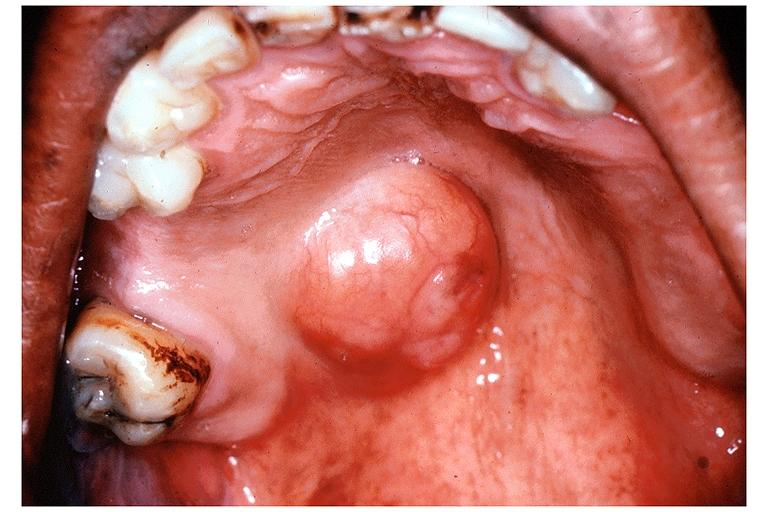does thecoma show pleomorphic adenoma benign mixed tumor?
Answer the question using a single word or phrase. No 